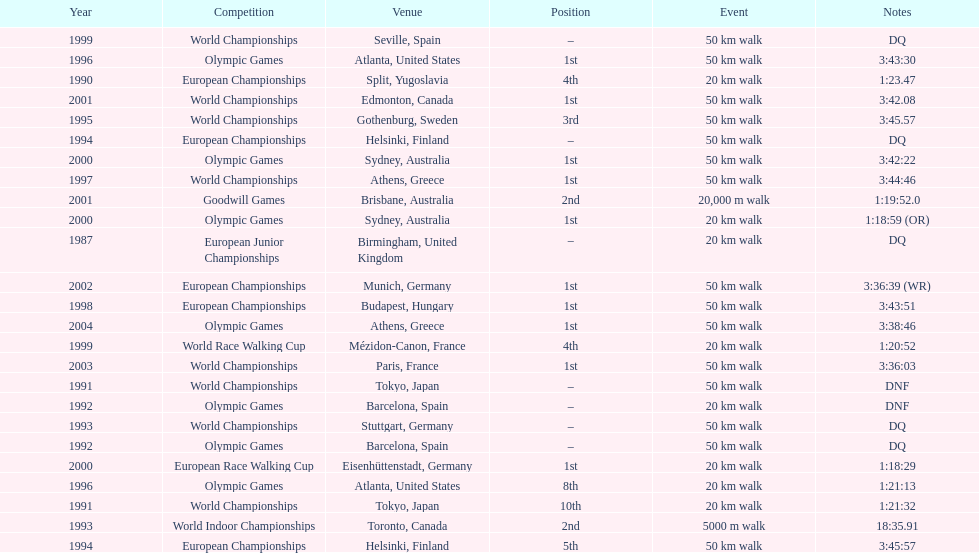In what year was korzeniowski's last competition? 2004. 